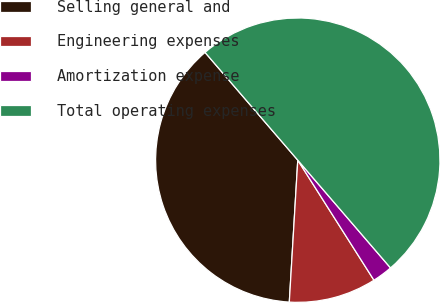<chart> <loc_0><loc_0><loc_500><loc_500><pie_chart><fcel>Selling general and<fcel>Engineering expenses<fcel>Amortization expense<fcel>Total operating expenses<nl><fcel>37.74%<fcel>9.95%<fcel>2.31%<fcel>50.0%<nl></chart> 